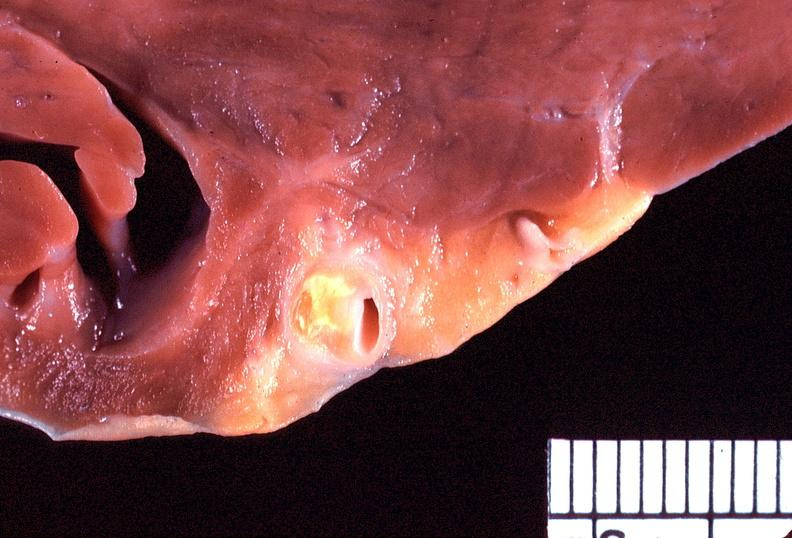what is present?
Answer the question using a single word or phrase. Cardiovascular 